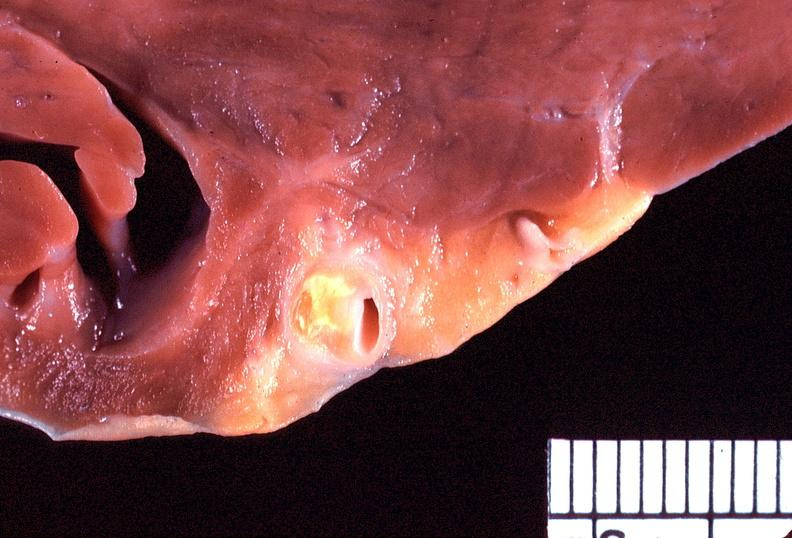what is present?
Answer the question using a single word or phrase. Cardiovascular 